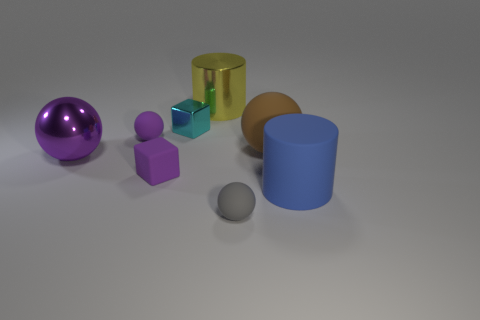Subtract all cyan balls. Subtract all yellow cubes. How many balls are left? 4 Add 2 matte cylinders. How many objects exist? 10 Subtract all cubes. How many objects are left? 6 Add 5 tiny cyan shiny blocks. How many tiny cyan shiny blocks exist? 6 Subtract 0 blue blocks. How many objects are left? 8 Subtract all gray things. Subtract all shiny cubes. How many objects are left? 6 Add 7 small cyan shiny blocks. How many small cyan shiny blocks are left? 8 